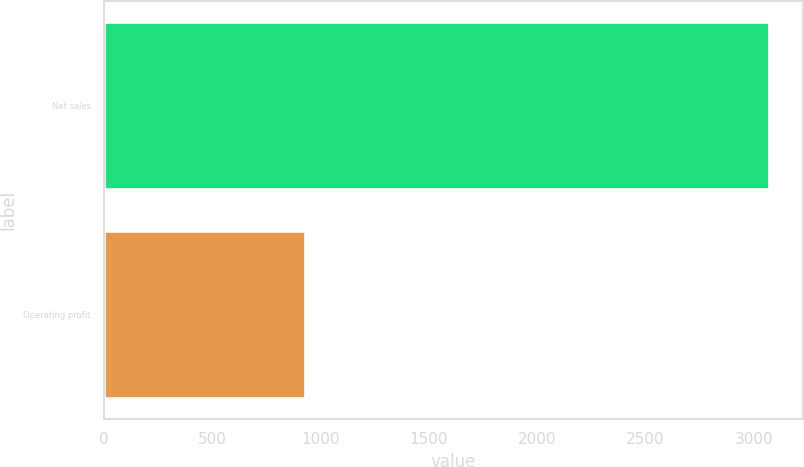<chart> <loc_0><loc_0><loc_500><loc_500><bar_chart><fcel>Net sales<fcel>Operating profit<nl><fcel>3072<fcel>927<nl></chart> 